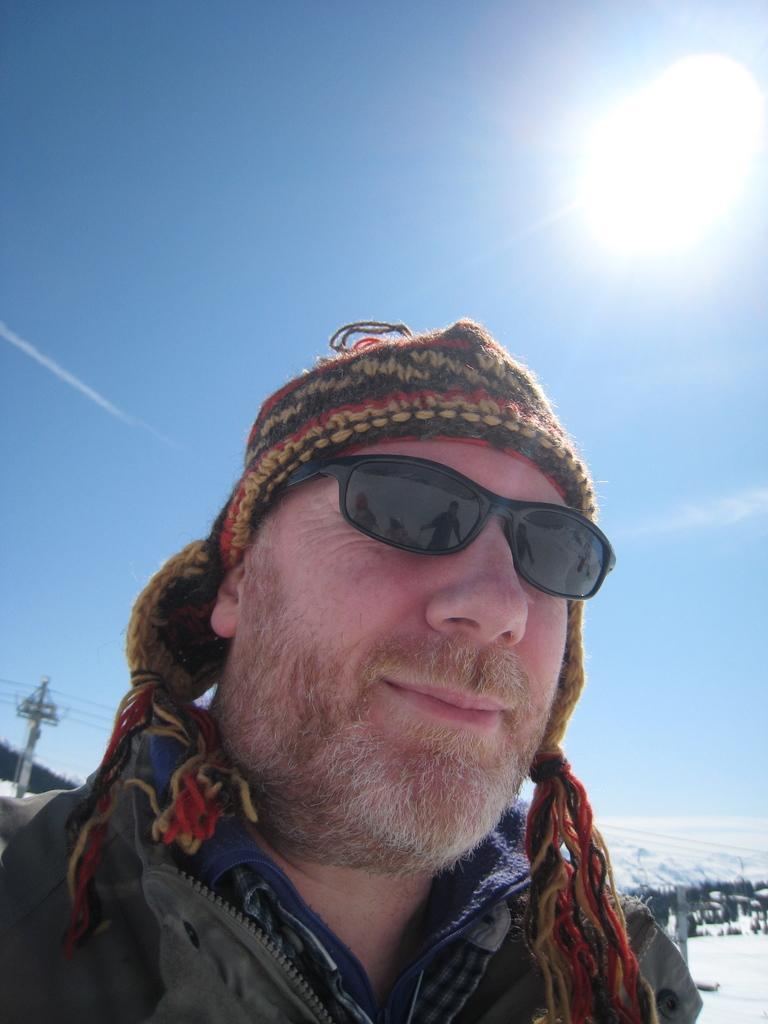How would you summarize this image in a sentence or two? In this picture we can observe a man wearing spectacles. He is smiling. There is a brown and yellow color cap on his head. On the left side there is a pole. In the background we can observe snow. There is a sky and a sun. 